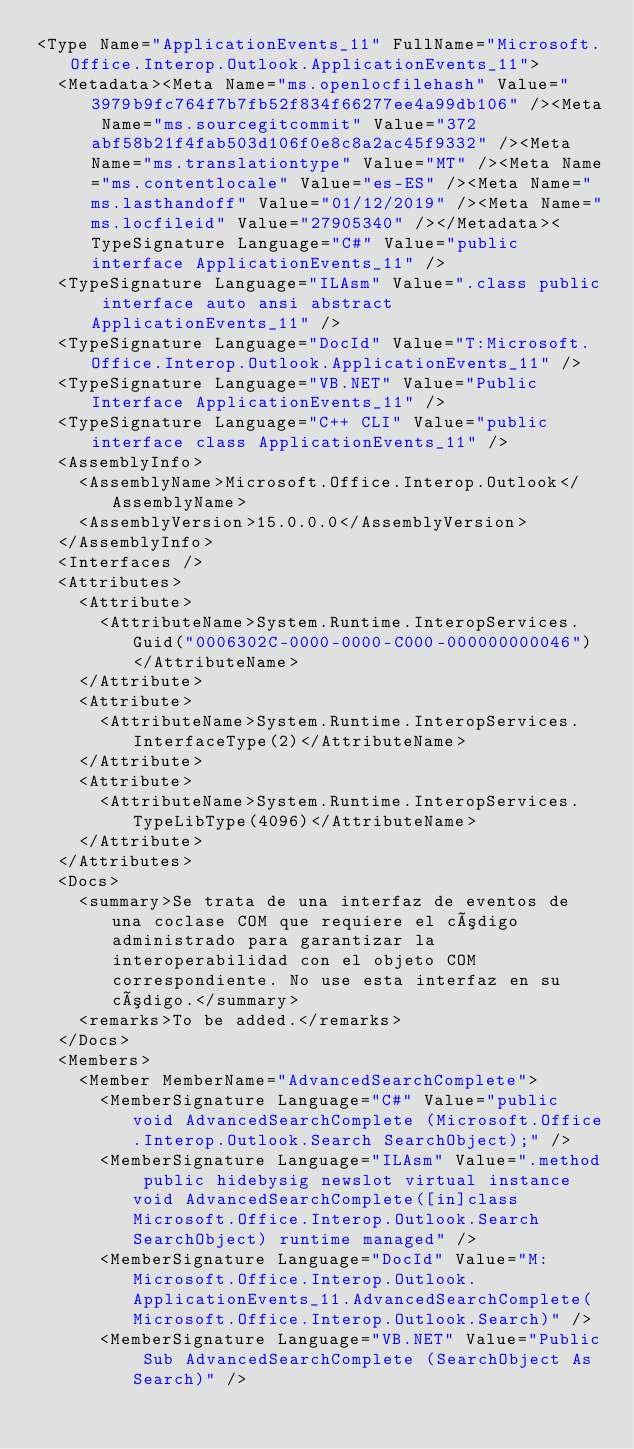<code> <loc_0><loc_0><loc_500><loc_500><_XML_><Type Name="ApplicationEvents_11" FullName="Microsoft.Office.Interop.Outlook.ApplicationEvents_11">
  <Metadata><Meta Name="ms.openlocfilehash" Value="3979b9fc764f7b7fb52f834f66277ee4a99db106" /><Meta Name="ms.sourcegitcommit" Value="372abf58b21f4fab503d106f0e8c8a2ac45f9332" /><Meta Name="ms.translationtype" Value="MT" /><Meta Name="ms.contentlocale" Value="es-ES" /><Meta Name="ms.lasthandoff" Value="01/12/2019" /><Meta Name="ms.locfileid" Value="27905340" /></Metadata><TypeSignature Language="C#" Value="public interface ApplicationEvents_11" />
  <TypeSignature Language="ILAsm" Value=".class public interface auto ansi abstract ApplicationEvents_11" />
  <TypeSignature Language="DocId" Value="T:Microsoft.Office.Interop.Outlook.ApplicationEvents_11" />
  <TypeSignature Language="VB.NET" Value="Public Interface ApplicationEvents_11" />
  <TypeSignature Language="C++ CLI" Value="public interface class ApplicationEvents_11" />
  <AssemblyInfo>
    <AssemblyName>Microsoft.Office.Interop.Outlook</AssemblyName>
    <AssemblyVersion>15.0.0.0</AssemblyVersion>
  </AssemblyInfo>
  <Interfaces />
  <Attributes>
    <Attribute>
      <AttributeName>System.Runtime.InteropServices.Guid("0006302C-0000-0000-C000-000000000046")</AttributeName>
    </Attribute>
    <Attribute>
      <AttributeName>System.Runtime.InteropServices.InterfaceType(2)</AttributeName>
    </Attribute>
    <Attribute>
      <AttributeName>System.Runtime.InteropServices.TypeLibType(4096)</AttributeName>
    </Attribute>
  </Attributes>
  <Docs>
    <summary>Se trata de una interfaz de eventos de una coclase COM que requiere el código administrado para garantizar la interoperabilidad con el objeto COM correspondiente. No use esta interfaz en su código.</summary>
    <remarks>To be added.</remarks>
  </Docs>
  <Members>
    <Member MemberName="AdvancedSearchComplete">
      <MemberSignature Language="C#" Value="public void AdvancedSearchComplete (Microsoft.Office.Interop.Outlook.Search SearchObject);" />
      <MemberSignature Language="ILAsm" Value=".method public hidebysig newslot virtual instance void AdvancedSearchComplete([in]class Microsoft.Office.Interop.Outlook.Search SearchObject) runtime managed" />
      <MemberSignature Language="DocId" Value="M:Microsoft.Office.Interop.Outlook.ApplicationEvents_11.AdvancedSearchComplete(Microsoft.Office.Interop.Outlook.Search)" />
      <MemberSignature Language="VB.NET" Value="Public Sub AdvancedSearchComplete (SearchObject As Search)" /></code> 